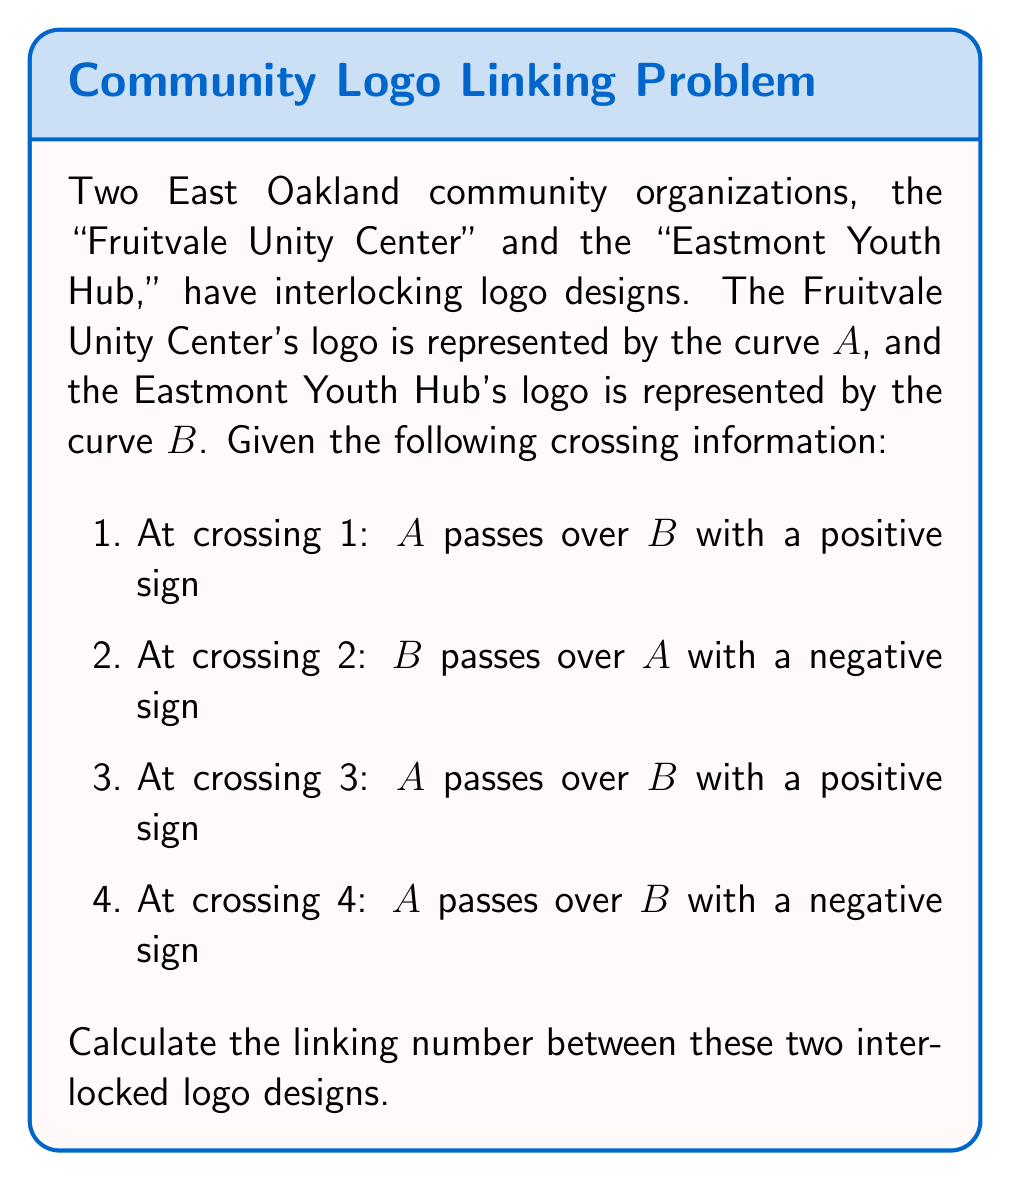Could you help me with this problem? To calculate the linking number between two curves, we follow these steps:

1. Identify all crossings where one curve passes over the other.
2. Assign a sign to each crossing (+1 for right-handed, -1 for left-handed).
3. Sum up all the signs.
4. Divide the sum by 2 to get the linking number.

Let's analyze each crossing:

1. Crossing 1: $A$ over $B$, positive sign. Contribution: $+1$
2. Crossing 2: $B$ over $A$, negative sign. Since we're considering $A$ over $B$, we reverse this. Contribution: $+1$
3. Crossing 3: $A$ over $B$, positive sign. Contribution: $+1$
4. Crossing 4: $A$ over $B$, negative sign. Contribution: $-1$

Now, let's sum up the contributions:

$$\text{Sum} = (+1) + (+1) + (+1) + (-1) = +2$$

Finally, we divide by 2 to get the linking number:

$$\text{Linking Number} = \frac{\text{Sum}}{2} = \frac{2}{2} = 1$$

Therefore, the linking number between the two interlocked logo designs is 1.
Answer: $1$ 